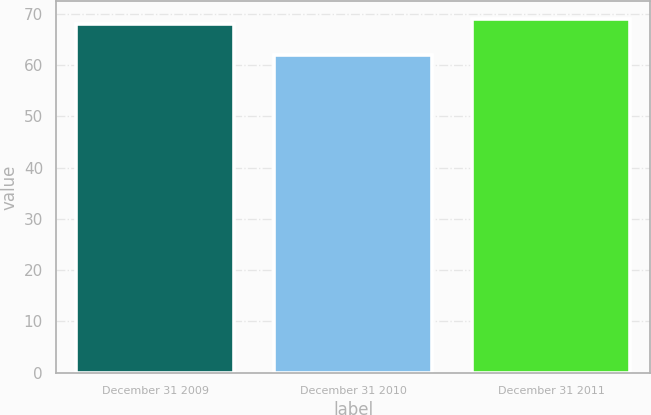Convert chart. <chart><loc_0><loc_0><loc_500><loc_500><bar_chart><fcel>December 31 2009<fcel>December 31 2010<fcel>December 31 2011<nl><fcel>68<fcel>62<fcel>69<nl></chart> 